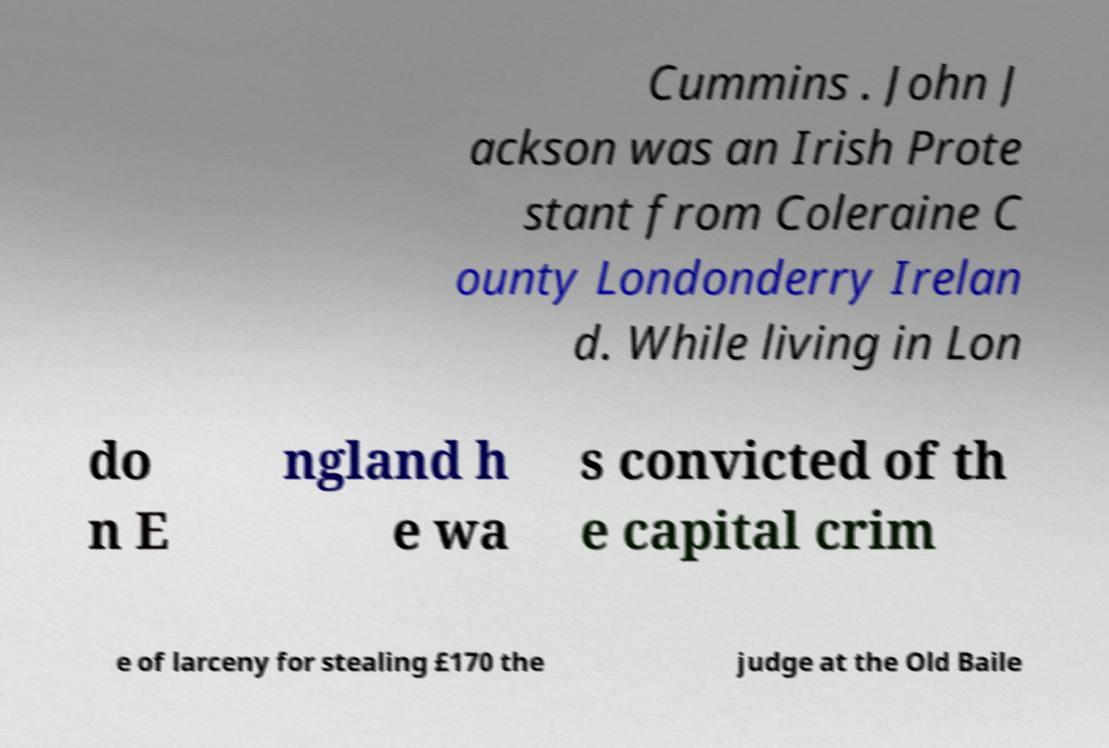Could you assist in decoding the text presented in this image and type it out clearly? Cummins . John J ackson was an Irish Prote stant from Coleraine C ounty Londonderry Irelan d. While living in Lon do n E ngland h e wa s convicted of th e capital crim e of larceny for stealing £170 the judge at the Old Baile 